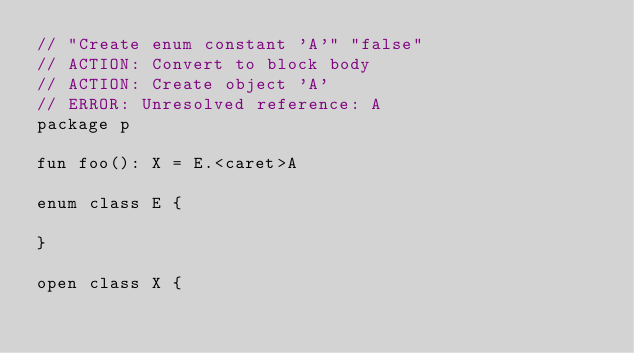<code> <loc_0><loc_0><loc_500><loc_500><_Kotlin_>// "Create enum constant 'A'" "false"
// ACTION: Convert to block body
// ACTION: Create object 'A'
// ERROR: Unresolved reference: A
package p

fun foo(): X = E.<caret>A

enum class E {

}

open class X {
</code> 